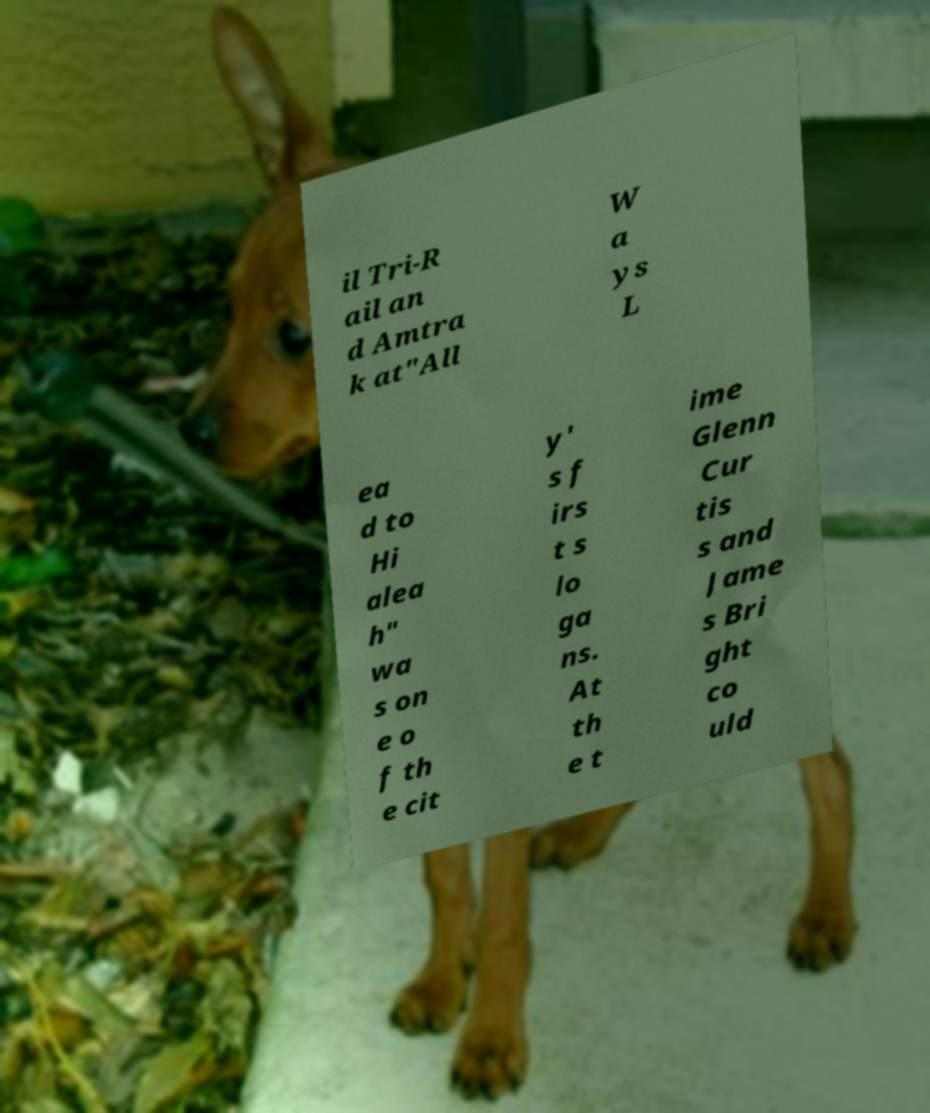Could you assist in decoding the text presented in this image and type it out clearly? il Tri-R ail an d Amtra k at"All W a ys L ea d to Hi alea h" wa s on e o f th e cit y' s f irs t s lo ga ns. At th e t ime Glenn Cur tis s and Jame s Bri ght co uld 